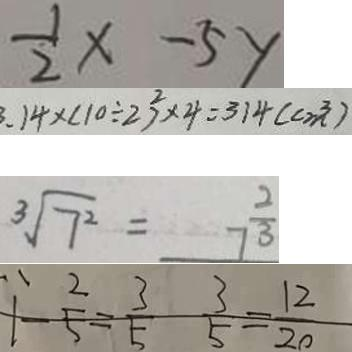<formula> <loc_0><loc_0><loc_500><loc_500>\frac { 1 } { 2 } x - 5 y 
 3 . 1 4 \times ( 1 0 \div 2 ) ^ { 2 } \times 4 = 3 1 4 ( c m ^ { 3 } ) 
 \sqrt [ 3 ] { 7 ^ { 2 } } = 7 ^ { \frac { 2 } { 3 } } 
 1 - \frac { 2 } { 5 } = \frac { 3 } { 5 } \frac { 3 } { 5 } = \frac { 1 2 } { 2 0 }</formula> 